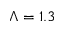<formula> <loc_0><loc_0><loc_500><loc_500>\Lambda = 1 . 3</formula> 